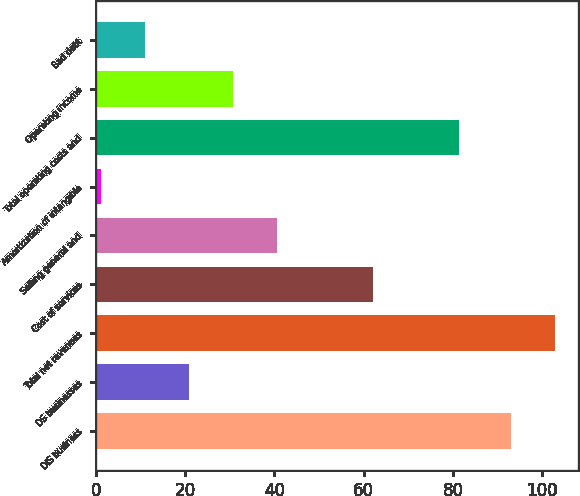<chart> <loc_0><loc_0><loc_500><loc_500><bar_chart><fcel>DIS business<fcel>DS businesses<fcel>Total net revenues<fcel>Cost of services<fcel>Selling general and<fcel>Amortization of intangible<fcel>Total operating costs and<fcel>Operating income<fcel>Bad debt<nl><fcel>93<fcel>20.88<fcel>102.89<fcel>62.1<fcel>40.66<fcel>1.1<fcel>81.3<fcel>30.77<fcel>10.99<nl></chart> 